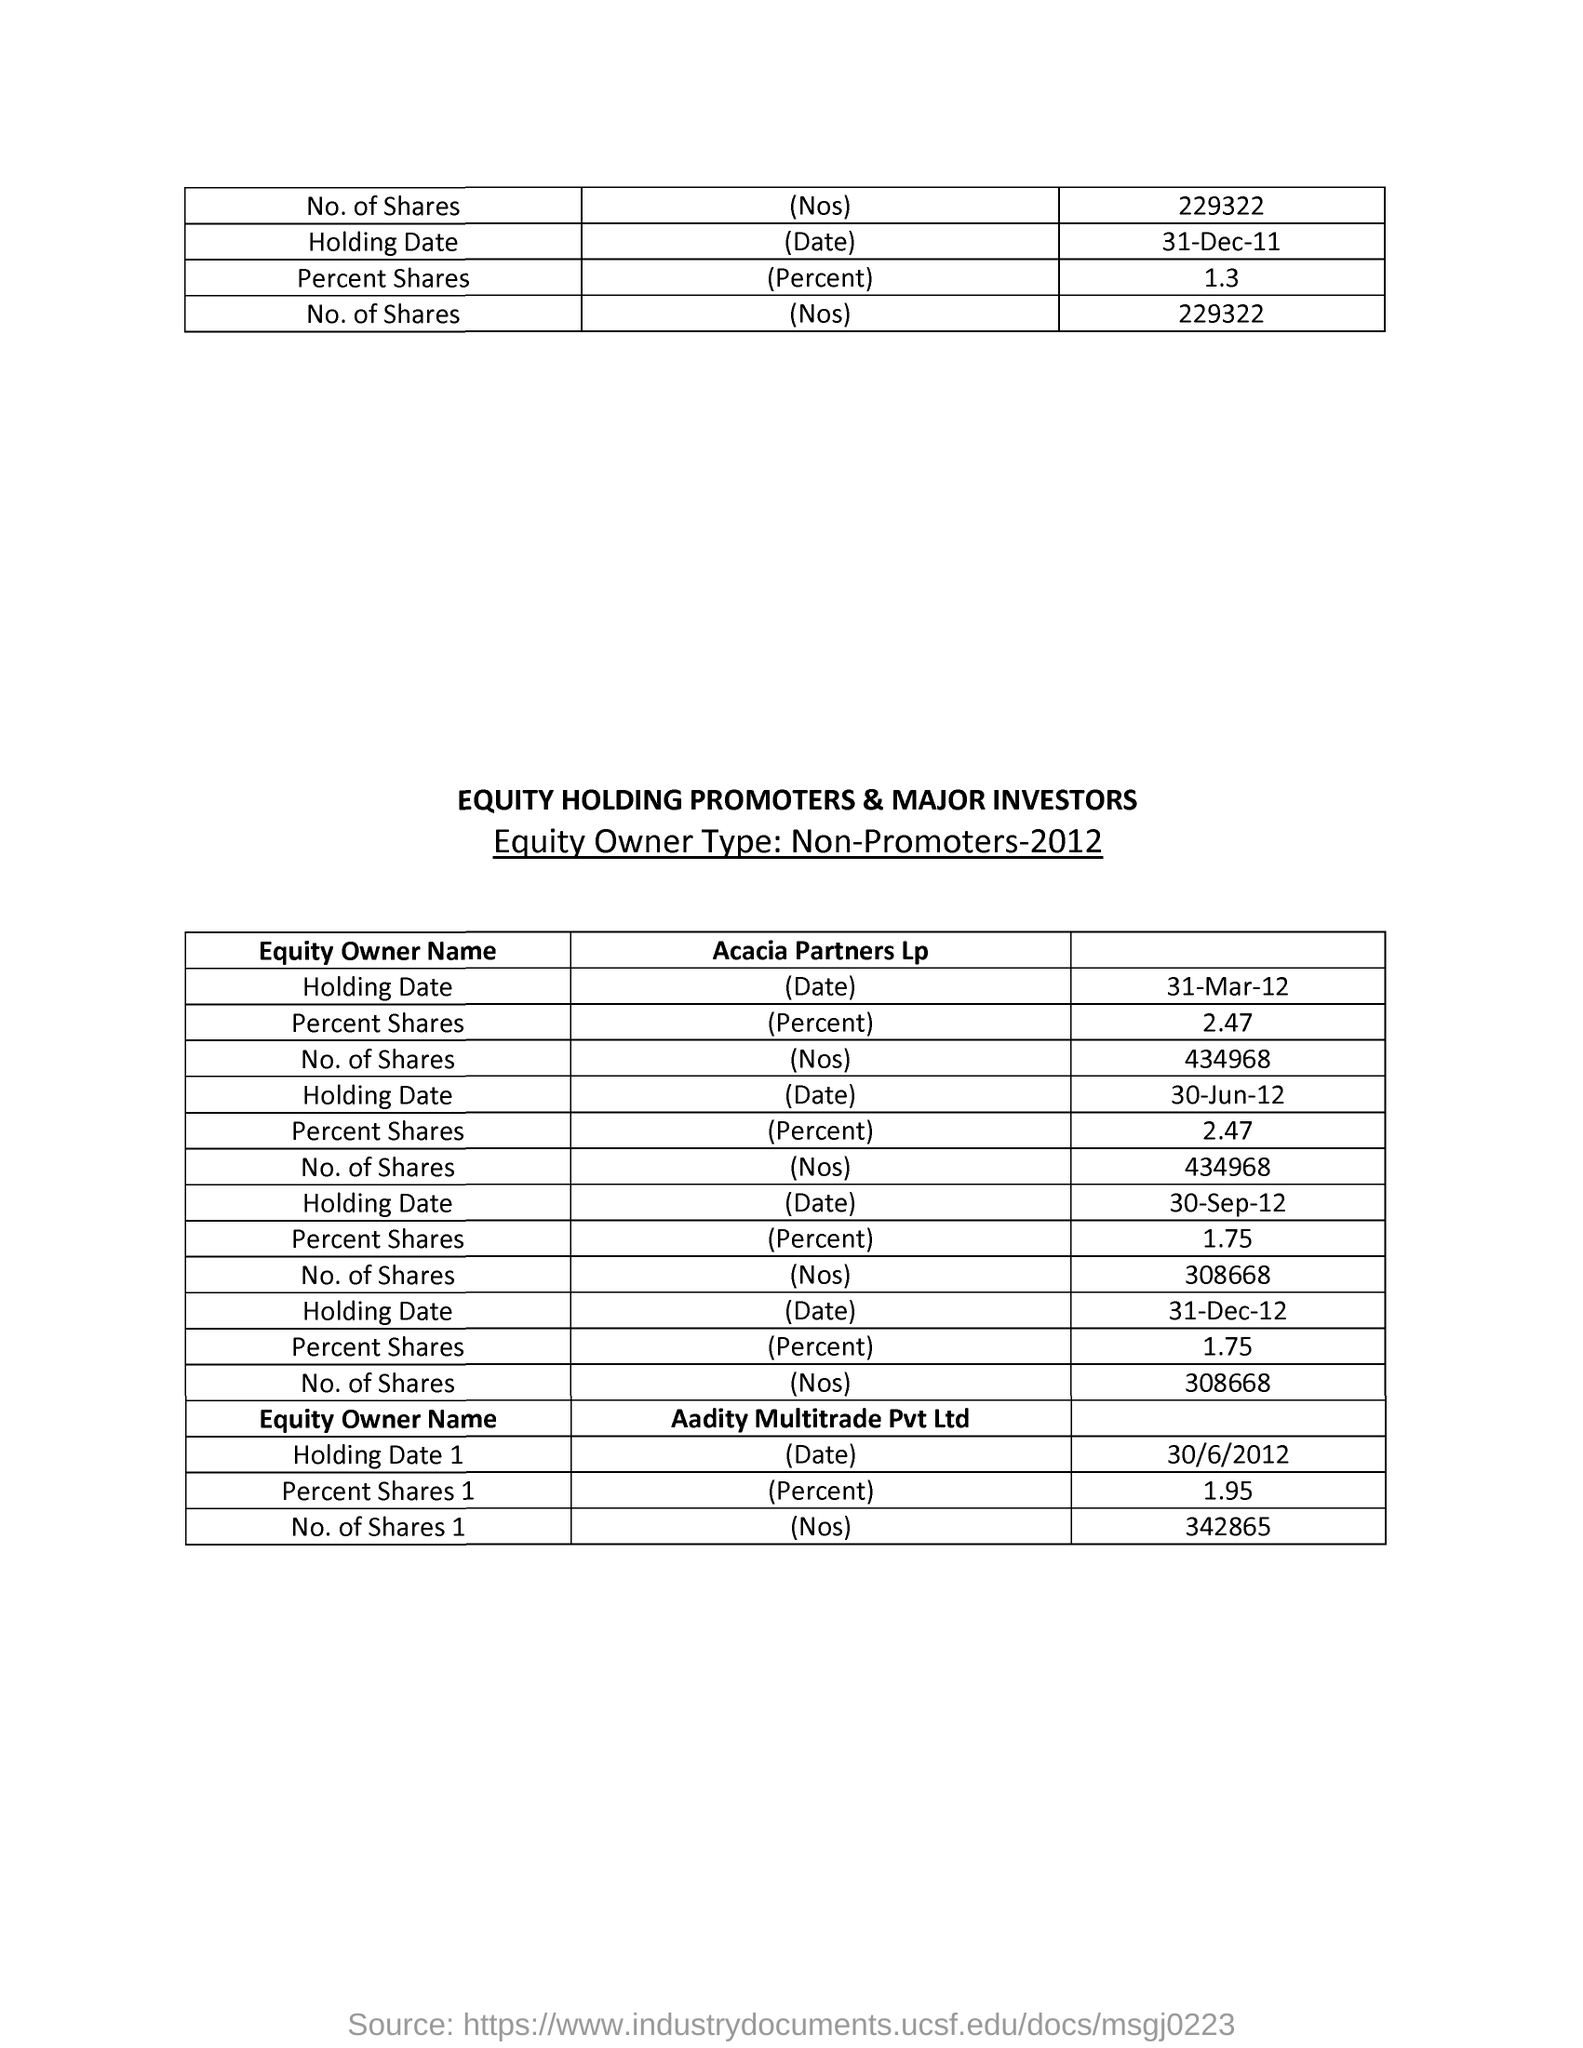What is the Equity Owner Name for percent shares 1 of 1.95?
Give a very brief answer. Aadity multitrade Pvt Ltd. 